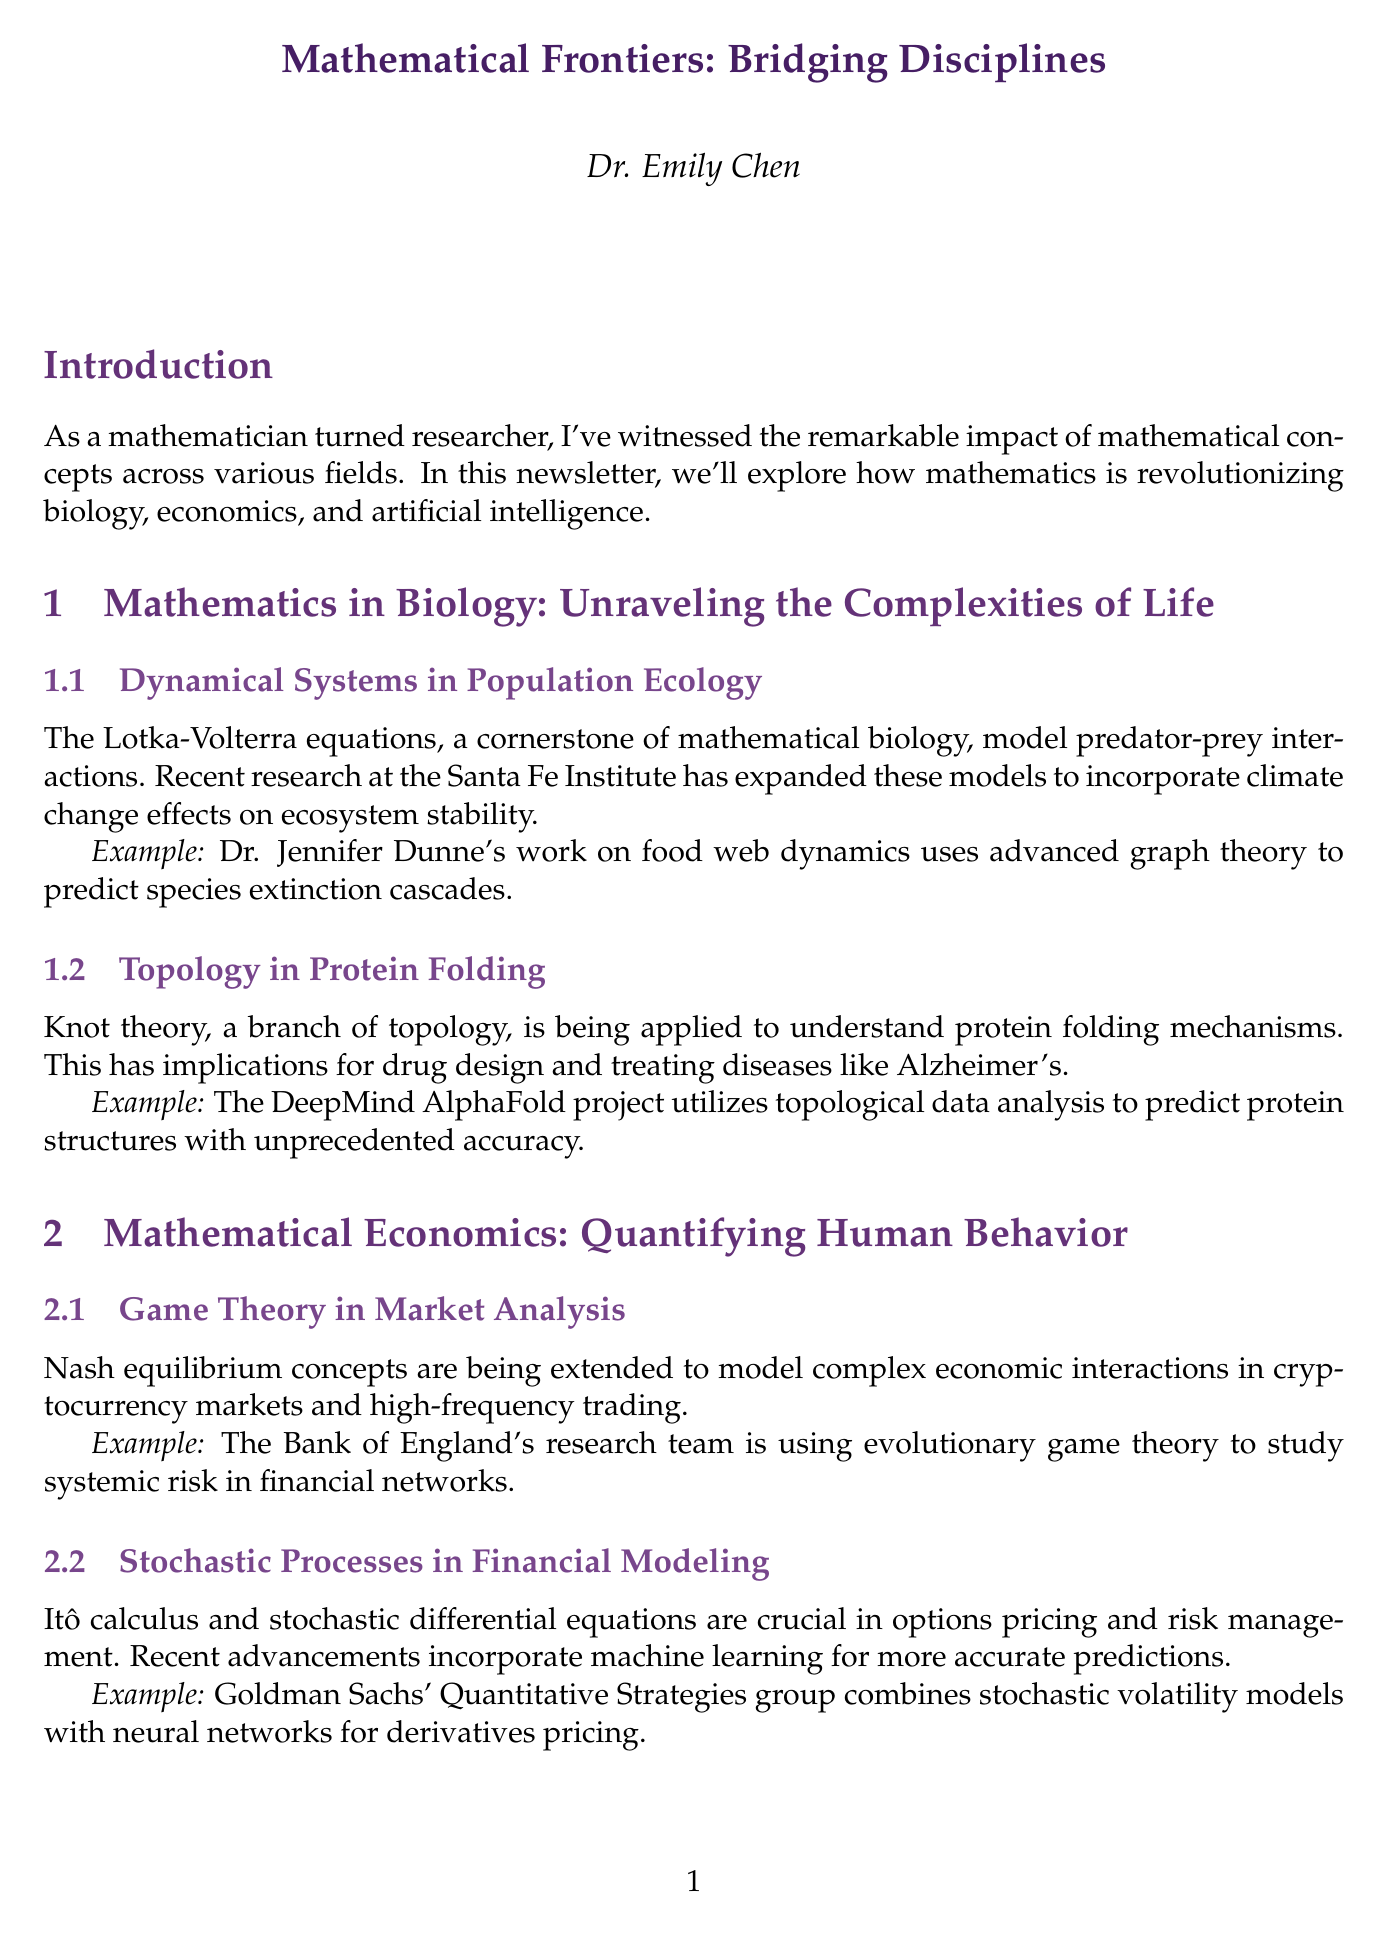what is the title of the newsletter? The title of the newsletter is mentioned prominently at the beginning of the document.
Answer: Mathematical Frontiers: Bridging Disciplines who is the author of the newsletter? The author's name is featured at the end of the newsletter alongside a brief bio.
Answer: Dr. Emily Chen what is the focus of Dr. Jennifer Dunne's work? The work of Dr. Jennifer Dunne is described in the context of a specific subtopic within the newsletter.
Answer: food web dynamics which mathematical concept is applied to understand protein folding mechanisms? The applied mathematical concept for protein folding mechanisms is noted under a specific subtopic.
Answer: knot theory what organization is studying systemic risk in financial networks? The document mentions a specific organization involved in research related to systemic risk.
Answer: Bank of England what theoretical framework is used in the DeepMind AlphaFold project? The project mentioned a specific type of analysis related to protein prediction.
Answer: topological data analysis what is the primary subject covered in the section on mathematical economics? The main focus of this section is encapsulated in a concise phrase summarizing its purpose.
Answer: Quantifying Human Behavior which optimization technique is highlighted in Google Brain's research? This question refers to a specific area of research mentioned in relation to machine learning.
Answer: sparse optimization techniques 